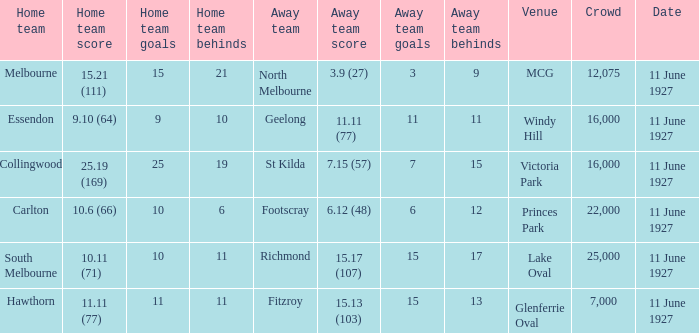Could you parse the entire table? {'header': ['Home team', 'Home team score', 'Home team goals', 'Home team behinds', 'Away team', 'Away team score', 'Away team goals', 'Away team behinds', 'Venue', 'Crowd', 'Date'], 'rows': [['Melbourne', '15.21 (111)', '15', '21', 'North Melbourne', '3.9 (27)', '3', '9', 'MCG', '12,075', '11 June 1927'], ['Essendon', '9.10 (64)', '9', '10', 'Geelong', '11.11 (77)', '11', '11', 'Windy Hill', '16,000', '11 June 1927'], ['Collingwood', '25.19 (169)', '25', '19', 'St Kilda', '7.15 (57)', '7', '15', 'Victoria Park', '16,000', '11 June 1927'], ['Carlton', '10.6 (66)', '10', '6', 'Footscray', '6.12 (48)', '6', '12', 'Princes Park', '22,000', '11 June 1927'], ['South Melbourne', '10.11 (71)', '10', '11', 'Richmond', '15.17 (107)', '15', '17', 'Lake Oval', '25,000', '11 June 1927'], ['Hawthorn', '11.11 (77)', '11', '11', 'Fitzroy', '15.13 (103)', '15', '13', 'Glenferrie Oval', '7,000', '11 June 1927']]} Which home team played against the visiting team geelong? Essendon. 